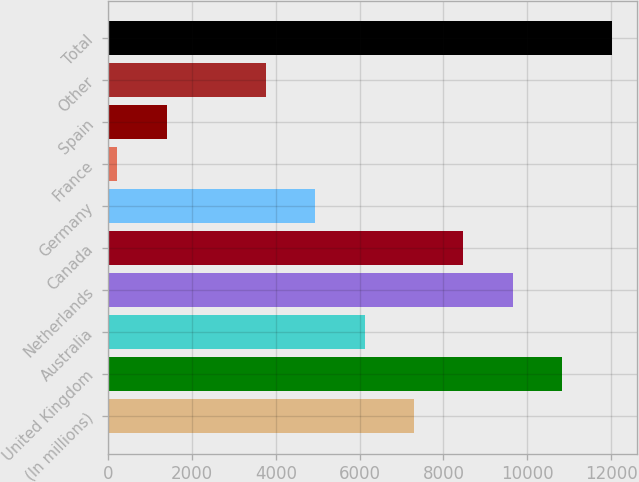Convert chart to OTSL. <chart><loc_0><loc_0><loc_500><loc_500><bar_chart><fcel>(In millions)<fcel>United Kingdom<fcel>Australia<fcel>Netherlands<fcel>Canada<fcel>Germany<fcel>France<fcel>Spain<fcel>Other<fcel>Total<nl><fcel>7297.8<fcel>10837.2<fcel>6118<fcel>9657.4<fcel>8477.6<fcel>4938.2<fcel>219<fcel>1398.8<fcel>3758.4<fcel>12017<nl></chart> 